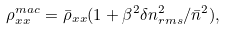<formula> <loc_0><loc_0><loc_500><loc_500>\rho ^ { m a c } _ { x x } = { \bar { \rho } } _ { x x } ( 1 + \beta ^ { 2 } \delta n _ { r m s } ^ { 2 } / { \bar { n } } ^ { 2 } ) ,</formula> 